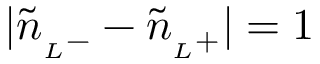<formula> <loc_0><loc_0><loc_500><loc_500>| \tilde { n } _ { L } - } - \tilde { n } _ { L } + } | = 1</formula> 